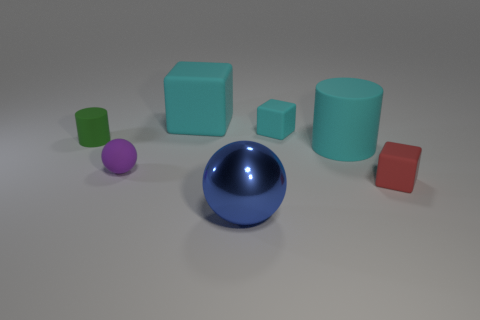Which object stands out the most, and why might that be? The large glossy blue sphere stands out the most due to its size, central placement, and reflective surface that catches the light, drawing the viewer's eye amidst the other matte-finished objects. 